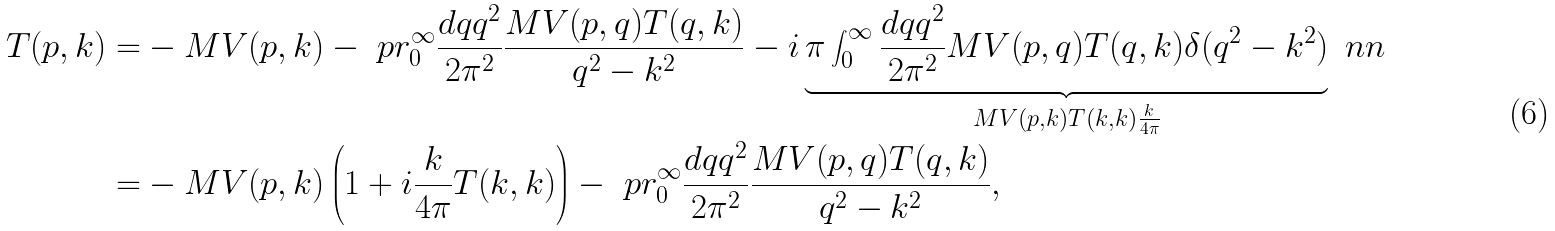<formula> <loc_0><loc_0><loc_500><loc_500>T ( p , k ) = & - M V ( p , k ) - \ p r _ { 0 } ^ { \infty } \frac { d q q ^ { 2 } } { 2 \pi ^ { 2 } } \frac { M V ( p , q ) T ( q , k ) } { q ^ { 2 } - k ^ { 2 } } - i \underbrace { \pi \int _ { 0 } ^ { \infty } \frac { d q q ^ { 2 } } { 2 \pi ^ { 2 } } M V ( p , q ) T ( q , k ) \delta ( q ^ { 2 } - k ^ { 2 } ) } _ { M V ( p , k ) T ( k , k ) \frac { k } { 4 \pi } } \ n n \\ = & - M V ( p , k ) \left ( 1 + i \frac { k } { 4 \pi } T ( k , k ) \right ) - \ p r _ { 0 } ^ { \infty } \frac { d q q ^ { 2 } } { 2 \pi ^ { 2 } } \frac { M V ( p , q ) T ( q , k ) } { q ^ { 2 } - k ^ { 2 } } ,</formula> 